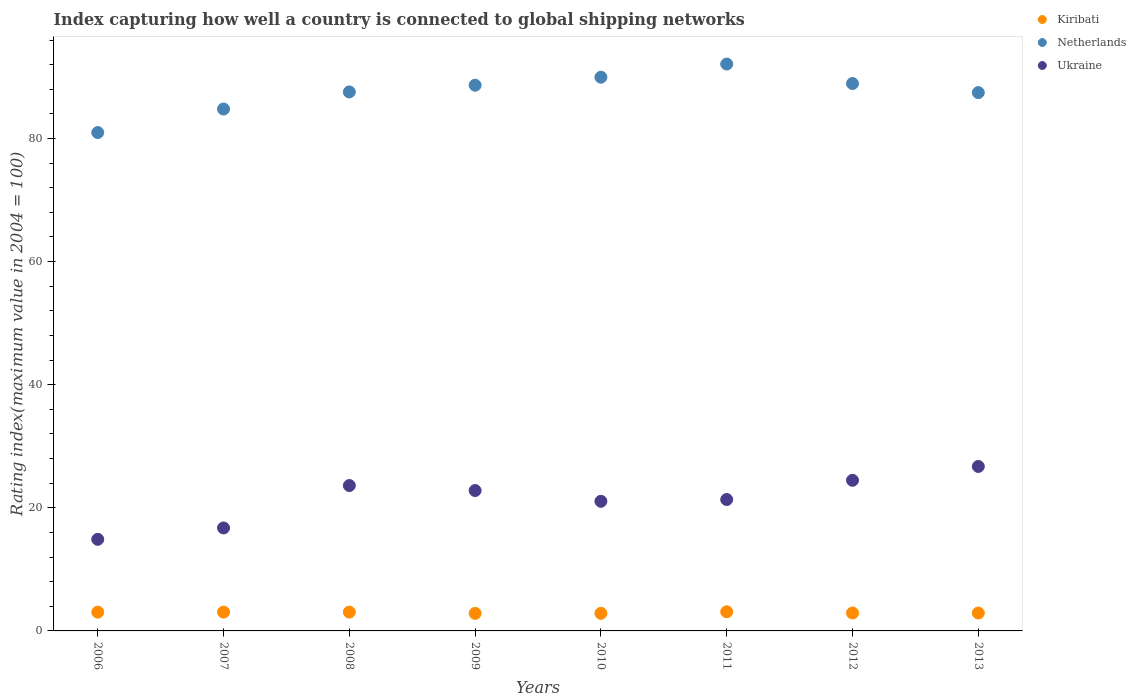Is the number of dotlines equal to the number of legend labels?
Make the answer very short. Yes. What is the rating index in Netherlands in 2009?
Keep it short and to the point. 88.66. Across all years, what is the maximum rating index in Kiribati?
Ensure brevity in your answer.  3.11. Across all years, what is the minimum rating index in Netherlands?
Your response must be concise. 80.97. In which year was the rating index in Ukraine maximum?
Make the answer very short. 2013. What is the total rating index in Kiribati in the graph?
Offer a terse response. 23.81. What is the difference between the rating index in Kiribati in 2009 and that in 2011?
Provide a short and direct response. -0.26. What is the difference between the rating index in Netherlands in 2012 and the rating index in Ukraine in 2009?
Keep it short and to the point. 66.12. What is the average rating index in Ukraine per year?
Your answer should be compact. 21.45. In the year 2013, what is the difference between the rating index in Ukraine and rating index in Kiribati?
Your answer should be very brief. 23.81. In how many years, is the rating index in Netherlands greater than 20?
Offer a very short reply. 8. What is the ratio of the rating index in Ukraine in 2009 to that in 2012?
Give a very brief answer. 0.93. What is the difference between the highest and the second highest rating index in Ukraine?
Offer a very short reply. 2.25. What is the difference between the highest and the lowest rating index in Netherlands?
Provide a short and direct response. 11.13. Is it the case that in every year, the sum of the rating index in Netherlands and rating index in Kiribati  is greater than the rating index in Ukraine?
Your response must be concise. Yes. Does the rating index in Ukraine monotonically increase over the years?
Offer a very short reply. No. Is the rating index in Kiribati strictly less than the rating index in Ukraine over the years?
Give a very brief answer. Yes. How many dotlines are there?
Your response must be concise. 3. How many years are there in the graph?
Give a very brief answer. 8. What is the difference between two consecutive major ticks on the Y-axis?
Provide a succinct answer. 20. How many legend labels are there?
Offer a terse response. 3. How are the legend labels stacked?
Keep it short and to the point. Vertical. What is the title of the graph?
Keep it short and to the point. Index capturing how well a country is connected to global shipping networks. What is the label or title of the X-axis?
Your answer should be very brief. Years. What is the label or title of the Y-axis?
Provide a succinct answer. Rating index(maximum value in 2004 = 100). What is the Rating index(maximum value in 2004 = 100) of Kiribati in 2006?
Provide a succinct answer. 3.05. What is the Rating index(maximum value in 2004 = 100) in Netherlands in 2006?
Offer a very short reply. 80.97. What is the Rating index(maximum value in 2004 = 100) of Ukraine in 2006?
Provide a short and direct response. 14.88. What is the Rating index(maximum value in 2004 = 100) in Kiribati in 2007?
Your answer should be very brief. 3.06. What is the Rating index(maximum value in 2004 = 100) in Netherlands in 2007?
Provide a succinct answer. 84.79. What is the Rating index(maximum value in 2004 = 100) in Ukraine in 2007?
Your answer should be very brief. 16.73. What is the Rating index(maximum value in 2004 = 100) of Kiribati in 2008?
Provide a succinct answer. 3.06. What is the Rating index(maximum value in 2004 = 100) of Netherlands in 2008?
Ensure brevity in your answer.  87.57. What is the Rating index(maximum value in 2004 = 100) in Ukraine in 2008?
Offer a very short reply. 23.62. What is the Rating index(maximum value in 2004 = 100) in Kiribati in 2009?
Provide a short and direct response. 2.85. What is the Rating index(maximum value in 2004 = 100) in Netherlands in 2009?
Provide a short and direct response. 88.66. What is the Rating index(maximum value in 2004 = 100) of Ukraine in 2009?
Provide a succinct answer. 22.81. What is the Rating index(maximum value in 2004 = 100) of Kiribati in 2010?
Offer a terse response. 2.86. What is the Rating index(maximum value in 2004 = 100) in Netherlands in 2010?
Your response must be concise. 89.96. What is the Rating index(maximum value in 2004 = 100) in Ukraine in 2010?
Give a very brief answer. 21.06. What is the Rating index(maximum value in 2004 = 100) of Kiribati in 2011?
Offer a very short reply. 3.11. What is the Rating index(maximum value in 2004 = 100) of Netherlands in 2011?
Your answer should be very brief. 92.1. What is the Rating index(maximum value in 2004 = 100) of Ukraine in 2011?
Offer a terse response. 21.35. What is the Rating index(maximum value in 2004 = 100) of Kiribati in 2012?
Your response must be concise. 2.91. What is the Rating index(maximum value in 2004 = 100) in Netherlands in 2012?
Provide a succinct answer. 88.93. What is the Rating index(maximum value in 2004 = 100) of Ukraine in 2012?
Provide a short and direct response. 24.47. What is the Rating index(maximum value in 2004 = 100) of Kiribati in 2013?
Your answer should be very brief. 2.91. What is the Rating index(maximum value in 2004 = 100) of Netherlands in 2013?
Offer a very short reply. 87.46. What is the Rating index(maximum value in 2004 = 100) in Ukraine in 2013?
Make the answer very short. 26.72. Across all years, what is the maximum Rating index(maximum value in 2004 = 100) of Kiribati?
Make the answer very short. 3.11. Across all years, what is the maximum Rating index(maximum value in 2004 = 100) in Netherlands?
Provide a succinct answer. 92.1. Across all years, what is the maximum Rating index(maximum value in 2004 = 100) in Ukraine?
Provide a short and direct response. 26.72. Across all years, what is the minimum Rating index(maximum value in 2004 = 100) of Kiribati?
Ensure brevity in your answer.  2.85. Across all years, what is the minimum Rating index(maximum value in 2004 = 100) of Netherlands?
Offer a terse response. 80.97. Across all years, what is the minimum Rating index(maximum value in 2004 = 100) of Ukraine?
Your answer should be compact. 14.88. What is the total Rating index(maximum value in 2004 = 100) in Kiribati in the graph?
Provide a short and direct response. 23.81. What is the total Rating index(maximum value in 2004 = 100) in Netherlands in the graph?
Offer a terse response. 700.44. What is the total Rating index(maximum value in 2004 = 100) in Ukraine in the graph?
Your answer should be compact. 171.64. What is the difference between the Rating index(maximum value in 2004 = 100) in Kiribati in 2006 and that in 2007?
Give a very brief answer. -0.01. What is the difference between the Rating index(maximum value in 2004 = 100) of Netherlands in 2006 and that in 2007?
Offer a terse response. -3.82. What is the difference between the Rating index(maximum value in 2004 = 100) of Ukraine in 2006 and that in 2007?
Offer a very short reply. -1.85. What is the difference between the Rating index(maximum value in 2004 = 100) of Kiribati in 2006 and that in 2008?
Offer a very short reply. -0.01. What is the difference between the Rating index(maximum value in 2004 = 100) in Netherlands in 2006 and that in 2008?
Your answer should be compact. -6.6. What is the difference between the Rating index(maximum value in 2004 = 100) in Ukraine in 2006 and that in 2008?
Your response must be concise. -8.74. What is the difference between the Rating index(maximum value in 2004 = 100) of Netherlands in 2006 and that in 2009?
Give a very brief answer. -7.69. What is the difference between the Rating index(maximum value in 2004 = 100) in Ukraine in 2006 and that in 2009?
Your response must be concise. -7.93. What is the difference between the Rating index(maximum value in 2004 = 100) of Kiribati in 2006 and that in 2010?
Provide a succinct answer. 0.19. What is the difference between the Rating index(maximum value in 2004 = 100) of Netherlands in 2006 and that in 2010?
Offer a terse response. -8.99. What is the difference between the Rating index(maximum value in 2004 = 100) of Ukraine in 2006 and that in 2010?
Your answer should be very brief. -6.18. What is the difference between the Rating index(maximum value in 2004 = 100) of Kiribati in 2006 and that in 2011?
Your answer should be compact. -0.06. What is the difference between the Rating index(maximum value in 2004 = 100) of Netherlands in 2006 and that in 2011?
Ensure brevity in your answer.  -11.13. What is the difference between the Rating index(maximum value in 2004 = 100) of Ukraine in 2006 and that in 2011?
Offer a terse response. -6.47. What is the difference between the Rating index(maximum value in 2004 = 100) of Kiribati in 2006 and that in 2012?
Provide a short and direct response. 0.14. What is the difference between the Rating index(maximum value in 2004 = 100) of Netherlands in 2006 and that in 2012?
Your answer should be very brief. -7.96. What is the difference between the Rating index(maximum value in 2004 = 100) of Ukraine in 2006 and that in 2012?
Make the answer very short. -9.59. What is the difference between the Rating index(maximum value in 2004 = 100) in Kiribati in 2006 and that in 2013?
Keep it short and to the point. 0.14. What is the difference between the Rating index(maximum value in 2004 = 100) in Netherlands in 2006 and that in 2013?
Offer a very short reply. -6.49. What is the difference between the Rating index(maximum value in 2004 = 100) in Ukraine in 2006 and that in 2013?
Offer a very short reply. -11.84. What is the difference between the Rating index(maximum value in 2004 = 100) of Netherlands in 2007 and that in 2008?
Provide a succinct answer. -2.78. What is the difference between the Rating index(maximum value in 2004 = 100) in Ukraine in 2007 and that in 2008?
Ensure brevity in your answer.  -6.89. What is the difference between the Rating index(maximum value in 2004 = 100) in Kiribati in 2007 and that in 2009?
Your response must be concise. 0.21. What is the difference between the Rating index(maximum value in 2004 = 100) in Netherlands in 2007 and that in 2009?
Keep it short and to the point. -3.87. What is the difference between the Rating index(maximum value in 2004 = 100) in Ukraine in 2007 and that in 2009?
Offer a terse response. -6.08. What is the difference between the Rating index(maximum value in 2004 = 100) of Kiribati in 2007 and that in 2010?
Provide a short and direct response. 0.2. What is the difference between the Rating index(maximum value in 2004 = 100) in Netherlands in 2007 and that in 2010?
Your response must be concise. -5.17. What is the difference between the Rating index(maximum value in 2004 = 100) of Ukraine in 2007 and that in 2010?
Your answer should be compact. -4.33. What is the difference between the Rating index(maximum value in 2004 = 100) of Kiribati in 2007 and that in 2011?
Your answer should be compact. -0.05. What is the difference between the Rating index(maximum value in 2004 = 100) in Netherlands in 2007 and that in 2011?
Your answer should be compact. -7.31. What is the difference between the Rating index(maximum value in 2004 = 100) of Ukraine in 2007 and that in 2011?
Your response must be concise. -4.62. What is the difference between the Rating index(maximum value in 2004 = 100) of Netherlands in 2007 and that in 2012?
Offer a very short reply. -4.14. What is the difference between the Rating index(maximum value in 2004 = 100) of Ukraine in 2007 and that in 2012?
Offer a very short reply. -7.74. What is the difference between the Rating index(maximum value in 2004 = 100) of Kiribati in 2007 and that in 2013?
Your response must be concise. 0.15. What is the difference between the Rating index(maximum value in 2004 = 100) of Netherlands in 2007 and that in 2013?
Provide a short and direct response. -2.67. What is the difference between the Rating index(maximum value in 2004 = 100) in Ukraine in 2007 and that in 2013?
Provide a short and direct response. -9.99. What is the difference between the Rating index(maximum value in 2004 = 100) in Kiribati in 2008 and that in 2009?
Keep it short and to the point. 0.21. What is the difference between the Rating index(maximum value in 2004 = 100) of Netherlands in 2008 and that in 2009?
Your answer should be compact. -1.09. What is the difference between the Rating index(maximum value in 2004 = 100) of Ukraine in 2008 and that in 2009?
Your response must be concise. 0.81. What is the difference between the Rating index(maximum value in 2004 = 100) in Kiribati in 2008 and that in 2010?
Your answer should be very brief. 0.2. What is the difference between the Rating index(maximum value in 2004 = 100) of Netherlands in 2008 and that in 2010?
Provide a short and direct response. -2.39. What is the difference between the Rating index(maximum value in 2004 = 100) in Ukraine in 2008 and that in 2010?
Keep it short and to the point. 2.56. What is the difference between the Rating index(maximum value in 2004 = 100) of Kiribati in 2008 and that in 2011?
Provide a short and direct response. -0.05. What is the difference between the Rating index(maximum value in 2004 = 100) of Netherlands in 2008 and that in 2011?
Make the answer very short. -4.53. What is the difference between the Rating index(maximum value in 2004 = 100) of Ukraine in 2008 and that in 2011?
Your answer should be compact. 2.27. What is the difference between the Rating index(maximum value in 2004 = 100) of Kiribati in 2008 and that in 2012?
Keep it short and to the point. 0.15. What is the difference between the Rating index(maximum value in 2004 = 100) in Netherlands in 2008 and that in 2012?
Make the answer very short. -1.36. What is the difference between the Rating index(maximum value in 2004 = 100) in Ukraine in 2008 and that in 2012?
Provide a short and direct response. -0.85. What is the difference between the Rating index(maximum value in 2004 = 100) in Netherlands in 2008 and that in 2013?
Your answer should be very brief. 0.11. What is the difference between the Rating index(maximum value in 2004 = 100) in Kiribati in 2009 and that in 2010?
Offer a very short reply. -0.01. What is the difference between the Rating index(maximum value in 2004 = 100) in Ukraine in 2009 and that in 2010?
Keep it short and to the point. 1.75. What is the difference between the Rating index(maximum value in 2004 = 100) of Kiribati in 2009 and that in 2011?
Your answer should be very brief. -0.26. What is the difference between the Rating index(maximum value in 2004 = 100) of Netherlands in 2009 and that in 2011?
Provide a short and direct response. -3.44. What is the difference between the Rating index(maximum value in 2004 = 100) in Ukraine in 2009 and that in 2011?
Your answer should be compact. 1.46. What is the difference between the Rating index(maximum value in 2004 = 100) in Kiribati in 2009 and that in 2012?
Offer a terse response. -0.06. What is the difference between the Rating index(maximum value in 2004 = 100) of Netherlands in 2009 and that in 2012?
Your answer should be compact. -0.27. What is the difference between the Rating index(maximum value in 2004 = 100) in Ukraine in 2009 and that in 2012?
Your response must be concise. -1.66. What is the difference between the Rating index(maximum value in 2004 = 100) of Kiribati in 2009 and that in 2013?
Offer a very short reply. -0.06. What is the difference between the Rating index(maximum value in 2004 = 100) in Ukraine in 2009 and that in 2013?
Provide a short and direct response. -3.91. What is the difference between the Rating index(maximum value in 2004 = 100) of Kiribati in 2010 and that in 2011?
Keep it short and to the point. -0.25. What is the difference between the Rating index(maximum value in 2004 = 100) of Netherlands in 2010 and that in 2011?
Your answer should be very brief. -2.14. What is the difference between the Rating index(maximum value in 2004 = 100) in Ukraine in 2010 and that in 2011?
Give a very brief answer. -0.29. What is the difference between the Rating index(maximum value in 2004 = 100) in Kiribati in 2010 and that in 2012?
Your answer should be compact. -0.05. What is the difference between the Rating index(maximum value in 2004 = 100) in Netherlands in 2010 and that in 2012?
Offer a very short reply. 1.03. What is the difference between the Rating index(maximum value in 2004 = 100) of Ukraine in 2010 and that in 2012?
Ensure brevity in your answer.  -3.41. What is the difference between the Rating index(maximum value in 2004 = 100) in Kiribati in 2010 and that in 2013?
Give a very brief answer. -0.05. What is the difference between the Rating index(maximum value in 2004 = 100) of Ukraine in 2010 and that in 2013?
Ensure brevity in your answer.  -5.66. What is the difference between the Rating index(maximum value in 2004 = 100) in Kiribati in 2011 and that in 2012?
Give a very brief answer. 0.2. What is the difference between the Rating index(maximum value in 2004 = 100) in Netherlands in 2011 and that in 2012?
Provide a succinct answer. 3.17. What is the difference between the Rating index(maximum value in 2004 = 100) in Ukraine in 2011 and that in 2012?
Make the answer very short. -3.12. What is the difference between the Rating index(maximum value in 2004 = 100) in Kiribati in 2011 and that in 2013?
Give a very brief answer. 0.2. What is the difference between the Rating index(maximum value in 2004 = 100) of Netherlands in 2011 and that in 2013?
Offer a very short reply. 4.64. What is the difference between the Rating index(maximum value in 2004 = 100) in Ukraine in 2011 and that in 2013?
Make the answer very short. -5.37. What is the difference between the Rating index(maximum value in 2004 = 100) in Kiribati in 2012 and that in 2013?
Provide a succinct answer. 0. What is the difference between the Rating index(maximum value in 2004 = 100) in Netherlands in 2012 and that in 2013?
Keep it short and to the point. 1.47. What is the difference between the Rating index(maximum value in 2004 = 100) in Ukraine in 2012 and that in 2013?
Provide a short and direct response. -2.25. What is the difference between the Rating index(maximum value in 2004 = 100) in Kiribati in 2006 and the Rating index(maximum value in 2004 = 100) in Netherlands in 2007?
Provide a succinct answer. -81.74. What is the difference between the Rating index(maximum value in 2004 = 100) of Kiribati in 2006 and the Rating index(maximum value in 2004 = 100) of Ukraine in 2007?
Your response must be concise. -13.68. What is the difference between the Rating index(maximum value in 2004 = 100) of Netherlands in 2006 and the Rating index(maximum value in 2004 = 100) of Ukraine in 2007?
Your answer should be very brief. 64.24. What is the difference between the Rating index(maximum value in 2004 = 100) in Kiribati in 2006 and the Rating index(maximum value in 2004 = 100) in Netherlands in 2008?
Make the answer very short. -84.52. What is the difference between the Rating index(maximum value in 2004 = 100) of Kiribati in 2006 and the Rating index(maximum value in 2004 = 100) of Ukraine in 2008?
Offer a terse response. -20.57. What is the difference between the Rating index(maximum value in 2004 = 100) in Netherlands in 2006 and the Rating index(maximum value in 2004 = 100) in Ukraine in 2008?
Provide a short and direct response. 57.35. What is the difference between the Rating index(maximum value in 2004 = 100) in Kiribati in 2006 and the Rating index(maximum value in 2004 = 100) in Netherlands in 2009?
Provide a short and direct response. -85.61. What is the difference between the Rating index(maximum value in 2004 = 100) in Kiribati in 2006 and the Rating index(maximum value in 2004 = 100) in Ukraine in 2009?
Ensure brevity in your answer.  -19.76. What is the difference between the Rating index(maximum value in 2004 = 100) of Netherlands in 2006 and the Rating index(maximum value in 2004 = 100) of Ukraine in 2009?
Offer a very short reply. 58.16. What is the difference between the Rating index(maximum value in 2004 = 100) in Kiribati in 2006 and the Rating index(maximum value in 2004 = 100) in Netherlands in 2010?
Ensure brevity in your answer.  -86.91. What is the difference between the Rating index(maximum value in 2004 = 100) in Kiribati in 2006 and the Rating index(maximum value in 2004 = 100) in Ukraine in 2010?
Provide a short and direct response. -18.01. What is the difference between the Rating index(maximum value in 2004 = 100) of Netherlands in 2006 and the Rating index(maximum value in 2004 = 100) of Ukraine in 2010?
Provide a short and direct response. 59.91. What is the difference between the Rating index(maximum value in 2004 = 100) in Kiribati in 2006 and the Rating index(maximum value in 2004 = 100) in Netherlands in 2011?
Keep it short and to the point. -89.05. What is the difference between the Rating index(maximum value in 2004 = 100) of Kiribati in 2006 and the Rating index(maximum value in 2004 = 100) of Ukraine in 2011?
Ensure brevity in your answer.  -18.3. What is the difference between the Rating index(maximum value in 2004 = 100) in Netherlands in 2006 and the Rating index(maximum value in 2004 = 100) in Ukraine in 2011?
Give a very brief answer. 59.62. What is the difference between the Rating index(maximum value in 2004 = 100) in Kiribati in 2006 and the Rating index(maximum value in 2004 = 100) in Netherlands in 2012?
Make the answer very short. -85.88. What is the difference between the Rating index(maximum value in 2004 = 100) of Kiribati in 2006 and the Rating index(maximum value in 2004 = 100) of Ukraine in 2012?
Provide a short and direct response. -21.42. What is the difference between the Rating index(maximum value in 2004 = 100) of Netherlands in 2006 and the Rating index(maximum value in 2004 = 100) of Ukraine in 2012?
Make the answer very short. 56.5. What is the difference between the Rating index(maximum value in 2004 = 100) in Kiribati in 2006 and the Rating index(maximum value in 2004 = 100) in Netherlands in 2013?
Give a very brief answer. -84.41. What is the difference between the Rating index(maximum value in 2004 = 100) in Kiribati in 2006 and the Rating index(maximum value in 2004 = 100) in Ukraine in 2013?
Offer a very short reply. -23.67. What is the difference between the Rating index(maximum value in 2004 = 100) in Netherlands in 2006 and the Rating index(maximum value in 2004 = 100) in Ukraine in 2013?
Provide a short and direct response. 54.25. What is the difference between the Rating index(maximum value in 2004 = 100) of Kiribati in 2007 and the Rating index(maximum value in 2004 = 100) of Netherlands in 2008?
Make the answer very short. -84.51. What is the difference between the Rating index(maximum value in 2004 = 100) of Kiribati in 2007 and the Rating index(maximum value in 2004 = 100) of Ukraine in 2008?
Give a very brief answer. -20.56. What is the difference between the Rating index(maximum value in 2004 = 100) of Netherlands in 2007 and the Rating index(maximum value in 2004 = 100) of Ukraine in 2008?
Your response must be concise. 61.17. What is the difference between the Rating index(maximum value in 2004 = 100) of Kiribati in 2007 and the Rating index(maximum value in 2004 = 100) of Netherlands in 2009?
Make the answer very short. -85.6. What is the difference between the Rating index(maximum value in 2004 = 100) of Kiribati in 2007 and the Rating index(maximum value in 2004 = 100) of Ukraine in 2009?
Provide a succinct answer. -19.75. What is the difference between the Rating index(maximum value in 2004 = 100) in Netherlands in 2007 and the Rating index(maximum value in 2004 = 100) in Ukraine in 2009?
Offer a very short reply. 61.98. What is the difference between the Rating index(maximum value in 2004 = 100) in Kiribati in 2007 and the Rating index(maximum value in 2004 = 100) in Netherlands in 2010?
Your answer should be compact. -86.9. What is the difference between the Rating index(maximum value in 2004 = 100) in Kiribati in 2007 and the Rating index(maximum value in 2004 = 100) in Ukraine in 2010?
Offer a terse response. -18. What is the difference between the Rating index(maximum value in 2004 = 100) in Netherlands in 2007 and the Rating index(maximum value in 2004 = 100) in Ukraine in 2010?
Your answer should be compact. 63.73. What is the difference between the Rating index(maximum value in 2004 = 100) of Kiribati in 2007 and the Rating index(maximum value in 2004 = 100) of Netherlands in 2011?
Offer a terse response. -89.04. What is the difference between the Rating index(maximum value in 2004 = 100) of Kiribati in 2007 and the Rating index(maximum value in 2004 = 100) of Ukraine in 2011?
Your answer should be very brief. -18.29. What is the difference between the Rating index(maximum value in 2004 = 100) in Netherlands in 2007 and the Rating index(maximum value in 2004 = 100) in Ukraine in 2011?
Keep it short and to the point. 63.44. What is the difference between the Rating index(maximum value in 2004 = 100) of Kiribati in 2007 and the Rating index(maximum value in 2004 = 100) of Netherlands in 2012?
Offer a very short reply. -85.87. What is the difference between the Rating index(maximum value in 2004 = 100) in Kiribati in 2007 and the Rating index(maximum value in 2004 = 100) in Ukraine in 2012?
Ensure brevity in your answer.  -21.41. What is the difference between the Rating index(maximum value in 2004 = 100) of Netherlands in 2007 and the Rating index(maximum value in 2004 = 100) of Ukraine in 2012?
Your answer should be very brief. 60.32. What is the difference between the Rating index(maximum value in 2004 = 100) in Kiribati in 2007 and the Rating index(maximum value in 2004 = 100) in Netherlands in 2013?
Offer a very short reply. -84.4. What is the difference between the Rating index(maximum value in 2004 = 100) in Kiribati in 2007 and the Rating index(maximum value in 2004 = 100) in Ukraine in 2013?
Ensure brevity in your answer.  -23.66. What is the difference between the Rating index(maximum value in 2004 = 100) in Netherlands in 2007 and the Rating index(maximum value in 2004 = 100) in Ukraine in 2013?
Offer a terse response. 58.07. What is the difference between the Rating index(maximum value in 2004 = 100) of Kiribati in 2008 and the Rating index(maximum value in 2004 = 100) of Netherlands in 2009?
Give a very brief answer. -85.6. What is the difference between the Rating index(maximum value in 2004 = 100) in Kiribati in 2008 and the Rating index(maximum value in 2004 = 100) in Ukraine in 2009?
Provide a succinct answer. -19.75. What is the difference between the Rating index(maximum value in 2004 = 100) in Netherlands in 2008 and the Rating index(maximum value in 2004 = 100) in Ukraine in 2009?
Your answer should be very brief. 64.76. What is the difference between the Rating index(maximum value in 2004 = 100) in Kiribati in 2008 and the Rating index(maximum value in 2004 = 100) in Netherlands in 2010?
Provide a short and direct response. -86.9. What is the difference between the Rating index(maximum value in 2004 = 100) of Netherlands in 2008 and the Rating index(maximum value in 2004 = 100) of Ukraine in 2010?
Keep it short and to the point. 66.51. What is the difference between the Rating index(maximum value in 2004 = 100) of Kiribati in 2008 and the Rating index(maximum value in 2004 = 100) of Netherlands in 2011?
Make the answer very short. -89.04. What is the difference between the Rating index(maximum value in 2004 = 100) of Kiribati in 2008 and the Rating index(maximum value in 2004 = 100) of Ukraine in 2011?
Offer a terse response. -18.29. What is the difference between the Rating index(maximum value in 2004 = 100) of Netherlands in 2008 and the Rating index(maximum value in 2004 = 100) of Ukraine in 2011?
Offer a very short reply. 66.22. What is the difference between the Rating index(maximum value in 2004 = 100) of Kiribati in 2008 and the Rating index(maximum value in 2004 = 100) of Netherlands in 2012?
Give a very brief answer. -85.87. What is the difference between the Rating index(maximum value in 2004 = 100) of Kiribati in 2008 and the Rating index(maximum value in 2004 = 100) of Ukraine in 2012?
Offer a terse response. -21.41. What is the difference between the Rating index(maximum value in 2004 = 100) of Netherlands in 2008 and the Rating index(maximum value in 2004 = 100) of Ukraine in 2012?
Ensure brevity in your answer.  63.1. What is the difference between the Rating index(maximum value in 2004 = 100) of Kiribati in 2008 and the Rating index(maximum value in 2004 = 100) of Netherlands in 2013?
Ensure brevity in your answer.  -84.4. What is the difference between the Rating index(maximum value in 2004 = 100) in Kiribati in 2008 and the Rating index(maximum value in 2004 = 100) in Ukraine in 2013?
Your answer should be compact. -23.66. What is the difference between the Rating index(maximum value in 2004 = 100) in Netherlands in 2008 and the Rating index(maximum value in 2004 = 100) in Ukraine in 2013?
Your answer should be compact. 60.85. What is the difference between the Rating index(maximum value in 2004 = 100) of Kiribati in 2009 and the Rating index(maximum value in 2004 = 100) of Netherlands in 2010?
Make the answer very short. -87.11. What is the difference between the Rating index(maximum value in 2004 = 100) in Kiribati in 2009 and the Rating index(maximum value in 2004 = 100) in Ukraine in 2010?
Make the answer very short. -18.21. What is the difference between the Rating index(maximum value in 2004 = 100) in Netherlands in 2009 and the Rating index(maximum value in 2004 = 100) in Ukraine in 2010?
Provide a succinct answer. 67.6. What is the difference between the Rating index(maximum value in 2004 = 100) of Kiribati in 2009 and the Rating index(maximum value in 2004 = 100) of Netherlands in 2011?
Offer a very short reply. -89.25. What is the difference between the Rating index(maximum value in 2004 = 100) of Kiribati in 2009 and the Rating index(maximum value in 2004 = 100) of Ukraine in 2011?
Keep it short and to the point. -18.5. What is the difference between the Rating index(maximum value in 2004 = 100) of Netherlands in 2009 and the Rating index(maximum value in 2004 = 100) of Ukraine in 2011?
Offer a very short reply. 67.31. What is the difference between the Rating index(maximum value in 2004 = 100) in Kiribati in 2009 and the Rating index(maximum value in 2004 = 100) in Netherlands in 2012?
Make the answer very short. -86.08. What is the difference between the Rating index(maximum value in 2004 = 100) in Kiribati in 2009 and the Rating index(maximum value in 2004 = 100) in Ukraine in 2012?
Your response must be concise. -21.62. What is the difference between the Rating index(maximum value in 2004 = 100) in Netherlands in 2009 and the Rating index(maximum value in 2004 = 100) in Ukraine in 2012?
Provide a short and direct response. 64.19. What is the difference between the Rating index(maximum value in 2004 = 100) in Kiribati in 2009 and the Rating index(maximum value in 2004 = 100) in Netherlands in 2013?
Offer a terse response. -84.61. What is the difference between the Rating index(maximum value in 2004 = 100) of Kiribati in 2009 and the Rating index(maximum value in 2004 = 100) of Ukraine in 2013?
Ensure brevity in your answer.  -23.87. What is the difference between the Rating index(maximum value in 2004 = 100) in Netherlands in 2009 and the Rating index(maximum value in 2004 = 100) in Ukraine in 2013?
Make the answer very short. 61.94. What is the difference between the Rating index(maximum value in 2004 = 100) of Kiribati in 2010 and the Rating index(maximum value in 2004 = 100) of Netherlands in 2011?
Provide a short and direct response. -89.24. What is the difference between the Rating index(maximum value in 2004 = 100) in Kiribati in 2010 and the Rating index(maximum value in 2004 = 100) in Ukraine in 2011?
Offer a very short reply. -18.49. What is the difference between the Rating index(maximum value in 2004 = 100) of Netherlands in 2010 and the Rating index(maximum value in 2004 = 100) of Ukraine in 2011?
Ensure brevity in your answer.  68.61. What is the difference between the Rating index(maximum value in 2004 = 100) in Kiribati in 2010 and the Rating index(maximum value in 2004 = 100) in Netherlands in 2012?
Your answer should be compact. -86.07. What is the difference between the Rating index(maximum value in 2004 = 100) in Kiribati in 2010 and the Rating index(maximum value in 2004 = 100) in Ukraine in 2012?
Provide a succinct answer. -21.61. What is the difference between the Rating index(maximum value in 2004 = 100) of Netherlands in 2010 and the Rating index(maximum value in 2004 = 100) of Ukraine in 2012?
Make the answer very short. 65.49. What is the difference between the Rating index(maximum value in 2004 = 100) of Kiribati in 2010 and the Rating index(maximum value in 2004 = 100) of Netherlands in 2013?
Your response must be concise. -84.6. What is the difference between the Rating index(maximum value in 2004 = 100) in Kiribati in 2010 and the Rating index(maximum value in 2004 = 100) in Ukraine in 2013?
Provide a succinct answer. -23.86. What is the difference between the Rating index(maximum value in 2004 = 100) in Netherlands in 2010 and the Rating index(maximum value in 2004 = 100) in Ukraine in 2013?
Offer a terse response. 63.24. What is the difference between the Rating index(maximum value in 2004 = 100) of Kiribati in 2011 and the Rating index(maximum value in 2004 = 100) of Netherlands in 2012?
Give a very brief answer. -85.82. What is the difference between the Rating index(maximum value in 2004 = 100) in Kiribati in 2011 and the Rating index(maximum value in 2004 = 100) in Ukraine in 2012?
Your answer should be very brief. -21.36. What is the difference between the Rating index(maximum value in 2004 = 100) of Netherlands in 2011 and the Rating index(maximum value in 2004 = 100) of Ukraine in 2012?
Ensure brevity in your answer.  67.63. What is the difference between the Rating index(maximum value in 2004 = 100) of Kiribati in 2011 and the Rating index(maximum value in 2004 = 100) of Netherlands in 2013?
Keep it short and to the point. -84.35. What is the difference between the Rating index(maximum value in 2004 = 100) in Kiribati in 2011 and the Rating index(maximum value in 2004 = 100) in Ukraine in 2013?
Give a very brief answer. -23.61. What is the difference between the Rating index(maximum value in 2004 = 100) in Netherlands in 2011 and the Rating index(maximum value in 2004 = 100) in Ukraine in 2013?
Offer a very short reply. 65.38. What is the difference between the Rating index(maximum value in 2004 = 100) of Kiribati in 2012 and the Rating index(maximum value in 2004 = 100) of Netherlands in 2013?
Your response must be concise. -84.55. What is the difference between the Rating index(maximum value in 2004 = 100) in Kiribati in 2012 and the Rating index(maximum value in 2004 = 100) in Ukraine in 2013?
Your response must be concise. -23.81. What is the difference between the Rating index(maximum value in 2004 = 100) in Netherlands in 2012 and the Rating index(maximum value in 2004 = 100) in Ukraine in 2013?
Make the answer very short. 62.21. What is the average Rating index(maximum value in 2004 = 100) in Kiribati per year?
Give a very brief answer. 2.98. What is the average Rating index(maximum value in 2004 = 100) in Netherlands per year?
Provide a succinct answer. 87.56. What is the average Rating index(maximum value in 2004 = 100) in Ukraine per year?
Ensure brevity in your answer.  21.45. In the year 2006, what is the difference between the Rating index(maximum value in 2004 = 100) of Kiribati and Rating index(maximum value in 2004 = 100) of Netherlands?
Provide a short and direct response. -77.92. In the year 2006, what is the difference between the Rating index(maximum value in 2004 = 100) of Kiribati and Rating index(maximum value in 2004 = 100) of Ukraine?
Give a very brief answer. -11.83. In the year 2006, what is the difference between the Rating index(maximum value in 2004 = 100) of Netherlands and Rating index(maximum value in 2004 = 100) of Ukraine?
Ensure brevity in your answer.  66.09. In the year 2007, what is the difference between the Rating index(maximum value in 2004 = 100) of Kiribati and Rating index(maximum value in 2004 = 100) of Netherlands?
Your response must be concise. -81.73. In the year 2007, what is the difference between the Rating index(maximum value in 2004 = 100) in Kiribati and Rating index(maximum value in 2004 = 100) in Ukraine?
Offer a terse response. -13.67. In the year 2007, what is the difference between the Rating index(maximum value in 2004 = 100) in Netherlands and Rating index(maximum value in 2004 = 100) in Ukraine?
Give a very brief answer. 68.06. In the year 2008, what is the difference between the Rating index(maximum value in 2004 = 100) in Kiribati and Rating index(maximum value in 2004 = 100) in Netherlands?
Provide a succinct answer. -84.51. In the year 2008, what is the difference between the Rating index(maximum value in 2004 = 100) of Kiribati and Rating index(maximum value in 2004 = 100) of Ukraine?
Offer a terse response. -20.56. In the year 2008, what is the difference between the Rating index(maximum value in 2004 = 100) in Netherlands and Rating index(maximum value in 2004 = 100) in Ukraine?
Ensure brevity in your answer.  63.95. In the year 2009, what is the difference between the Rating index(maximum value in 2004 = 100) in Kiribati and Rating index(maximum value in 2004 = 100) in Netherlands?
Your answer should be compact. -85.81. In the year 2009, what is the difference between the Rating index(maximum value in 2004 = 100) in Kiribati and Rating index(maximum value in 2004 = 100) in Ukraine?
Provide a succinct answer. -19.96. In the year 2009, what is the difference between the Rating index(maximum value in 2004 = 100) of Netherlands and Rating index(maximum value in 2004 = 100) of Ukraine?
Offer a terse response. 65.85. In the year 2010, what is the difference between the Rating index(maximum value in 2004 = 100) in Kiribati and Rating index(maximum value in 2004 = 100) in Netherlands?
Provide a succinct answer. -87.1. In the year 2010, what is the difference between the Rating index(maximum value in 2004 = 100) in Kiribati and Rating index(maximum value in 2004 = 100) in Ukraine?
Offer a terse response. -18.2. In the year 2010, what is the difference between the Rating index(maximum value in 2004 = 100) of Netherlands and Rating index(maximum value in 2004 = 100) of Ukraine?
Provide a short and direct response. 68.9. In the year 2011, what is the difference between the Rating index(maximum value in 2004 = 100) in Kiribati and Rating index(maximum value in 2004 = 100) in Netherlands?
Keep it short and to the point. -88.99. In the year 2011, what is the difference between the Rating index(maximum value in 2004 = 100) of Kiribati and Rating index(maximum value in 2004 = 100) of Ukraine?
Give a very brief answer. -18.24. In the year 2011, what is the difference between the Rating index(maximum value in 2004 = 100) of Netherlands and Rating index(maximum value in 2004 = 100) of Ukraine?
Provide a succinct answer. 70.75. In the year 2012, what is the difference between the Rating index(maximum value in 2004 = 100) of Kiribati and Rating index(maximum value in 2004 = 100) of Netherlands?
Your answer should be compact. -86.02. In the year 2012, what is the difference between the Rating index(maximum value in 2004 = 100) of Kiribati and Rating index(maximum value in 2004 = 100) of Ukraine?
Keep it short and to the point. -21.56. In the year 2012, what is the difference between the Rating index(maximum value in 2004 = 100) of Netherlands and Rating index(maximum value in 2004 = 100) of Ukraine?
Offer a terse response. 64.46. In the year 2013, what is the difference between the Rating index(maximum value in 2004 = 100) in Kiribati and Rating index(maximum value in 2004 = 100) in Netherlands?
Offer a terse response. -84.55. In the year 2013, what is the difference between the Rating index(maximum value in 2004 = 100) in Kiribati and Rating index(maximum value in 2004 = 100) in Ukraine?
Ensure brevity in your answer.  -23.81. In the year 2013, what is the difference between the Rating index(maximum value in 2004 = 100) of Netherlands and Rating index(maximum value in 2004 = 100) of Ukraine?
Your answer should be compact. 60.74. What is the ratio of the Rating index(maximum value in 2004 = 100) in Kiribati in 2006 to that in 2007?
Offer a terse response. 1. What is the ratio of the Rating index(maximum value in 2004 = 100) of Netherlands in 2006 to that in 2007?
Your answer should be very brief. 0.95. What is the ratio of the Rating index(maximum value in 2004 = 100) of Ukraine in 2006 to that in 2007?
Keep it short and to the point. 0.89. What is the ratio of the Rating index(maximum value in 2004 = 100) in Netherlands in 2006 to that in 2008?
Ensure brevity in your answer.  0.92. What is the ratio of the Rating index(maximum value in 2004 = 100) of Ukraine in 2006 to that in 2008?
Provide a succinct answer. 0.63. What is the ratio of the Rating index(maximum value in 2004 = 100) of Kiribati in 2006 to that in 2009?
Provide a succinct answer. 1.07. What is the ratio of the Rating index(maximum value in 2004 = 100) in Netherlands in 2006 to that in 2009?
Keep it short and to the point. 0.91. What is the ratio of the Rating index(maximum value in 2004 = 100) of Ukraine in 2006 to that in 2009?
Make the answer very short. 0.65. What is the ratio of the Rating index(maximum value in 2004 = 100) in Kiribati in 2006 to that in 2010?
Keep it short and to the point. 1.07. What is the ratio of the Rating index(maximum value in 2004 = 100) of Netherlands in 2006 to that in 2010?
Offer a very short reply. 0.9. What is the ratio of the Rating index(maximum value in 2004 = 100) in Ukraine in 2006 to that in 2010?
Your answer should be very brief. 0.71. What is the ratio of the Rating index(maximum value in 2004 = 100) of Kiribati in 2006 to that in 2011?
Keep it short and to the point. 0.98. What is the ratio of the Rating index(maximum value in 2004 = 100) of Netherlands in 2006 to that in 2011?
Your answer should be compact. 0.88. What is the ratio of the Rating index(maximum value in 2004 = 100) in Ukraine in 2006 to that in 2011?
Provide a succinct answer. 0.7. What is the ratio of the Rating index(maximum value in 2004 = 100) in Kiribati in 2006 to that in 2012?
Offer a terse response. 1.05. What is the ratio of the Rating index(maximum value in 2004 = 100) in Netherlands in 2006 to that in 2012?
Your response must be concise. 0.91. What is the ratio of the Rating index(maximum value in 2004 = 100) in Ukraine in 2006 to that in 2012?
Keep it short and to the point. 0.61. What is the ratio of the Rating index(maximum value in 2004 = 100) in Kiribati in 2006 to that in 2013?
Your response must be concise. 1.05. What is the ratio of the Rating index(maximum value in 2004 = 100) in Netherlands in 2006 to that in 2013?
Keep it short and to the point. 0.93. What is the ratio of the Rating index(maximum value in 2004 = 100) in Ukraine in 2006 to that in 2013?
Your response must be concise. 0.56. What is the ratio of the Rating index(maximum value in 2004 = 100) of Netherlands in 2007 to that in 2008?
Provide a succinct answer. 0.97. What is the ratio of the Rating index(maximum value in 2004 = 100) in Ukraine in 2007 to that in 2008?
Make the answer very short. 0.71. What is the ratio of the Rating index(maximum value in 2004 = 100) in Kiribati in 2007 to that in 2009?
Give a very brief answer. 1.07. What is the ratio of the Rating index(maximum value in 2004 = 100) of Netherlands in 2007 to that in 2009?
Ensure brevity in your answer.  0.96. What is the ratio of the Rating index(maximum value in 2004 = 100) in Ukraine in 2007 to that in 2009?
Provide a succinct answer. 0.73. What is the ratio of the Rating index(maximum value in 2004 = 100) of Kiribati in 2007 to that in 2010?
Your response must be concise. 1.07. What is the ratio of the Rating index(maximum value in 2004 = 100) of Netherlands in 2007 to that in 2010?
Your response must be concise. 0.94. What is the ratio of the Rating index(maximum value in 2004 = 100) of Ukraine in 2007 to that in 2010?
Give a very brief answer. 0.79. What is the ratio of the Rating index(maximum value in 2004 = 100) of Kiribati in 2007 to that in 2011?
Make the answer very short. 0.98. What is the ratio of the Rating index(maximum value in 2004 = 100) of Netherlands in 2007 to that in 2011?
Your response must be concise. 0.92. What is the ratio of the Rating index(maximum value in 2004 = 100) in Ukraine in 2007 to that in 2011?
Provide a short and direct response. 0.78. What is the ratio of the Rating index(maximum value in 2004 = 100) of Kiribati in 2007 to that in 2012?
Make the answer very short. 1.05. What is the ratio of the Rating index(maximum value in 2004 = 100) in Netherlands in 2007 to that in 2012?
Provide a short and direct response. 0.95. What is the ratio of the Rating index(maximum value in 2004 = 100) in Ukraine in 2007 to that in 2012?
Your response must be concise. 0.68. What is the ratio of the Rating index(maximum value in 2004 = 100) of Kiribati in 2007 to that in 2013?
Provide a succinct answer. 1.05. What is the ratio of the Rating index(maximum value in 2004 = 100) of Netherlands in 2007 to that in 2013?
Ensure brevity in your answer.  0.97. What is the ratio of the Rating index(maximum value in 2004 = 100) in Ukraine in 2007 to that in 2013?
Provide a short and direct response. 0.63. What is the ratio of the Rating index(maximum value in 2004 = 100) in Kiribati in 2008 to that in 2009?
Your answer should be compact. 1.07. What is the ratio of the Rating index(maximum value in 2004 = 100) of Ukraine in 2008 to that in 2009?
Make the answer very short. 1.04. What is the ratio of the Rating index(maximum value in 2004 = 100) in Kiribati in 2008 to that in 2010?
Make the answer very short. 1.07. What is the ratio of the Rating index(maximum value in 2004 = 100) of Netherlands in 2008 to that in 2010?
Provide a succinct answer. 0.97. What is the ratio of the Rating index(maximum value in 2004 = 100) of Ukraine in 2008 to that in 2010?
Make the answer very short. 1.12. What is the ratio of the Rating index(maximum value in 2004 = 100) of Kiribati in 2008 to that in 2011?
Offer a terse response. 0.98. What is the ratio of the Rating index(maximum value in 2004 = 100) of Netherlands in 2008 to that in 2011?
Your response must be concise. 0.95. What is the ratio of the Rating index(maximum value in 2004 = 100) in Ukraine in 2008 to that in 2011?
Provide a short and direct response. 1.11. What is the ratio of the Rating index(maximum value in 2004 = 100) of Kiribati in 2008 to that in 2012?
Make the answer very short. 1.05. What is the ratio of the Rating index(maximum value in 2004 = 100) in Netherlands in 2008 to that in 2012?
Your answer should be compact. 0.98. What is the ratio of the Rating index(maximum value in 2004 = 100) of Ukraine in 2008 to that in 2012?
Your response must be concise. 0.97. What is the ratio of the Rating index(maximum value in 2004 = 100) of Kiribati in 2008 to that in 2013?
Offer a terse response. 1.05. What is the ratio of the Rating index(maximum value in 2004 = 100) of Ukraine in 2008 to that in 2013?
Your response must be concise. 0.88. What is the ratio of the Rating index(maximum value in 2004 = 100) of Netherlands in 2009 to that in 2010?
Your response must be concise. 0.99. What is the ratio of the Rating index(maximum value in 2004 = 100) of Ukraine in 2009 to that in 2010?
Give a very brief answer. 1.08. What is the ratio of the Rating index(maximum value in 2004 = 100) in Kiribati in 2009 to that in 2011?
Offer a very short reply. 0.92. What is the ratio of the Rating index(maximum value in 2004 = 100) of Netherlands in 2009 to that in 2011?
Give a very brief answer. 0.96. What is the ratio of the Rating index(maximum value in 2004 = 100) in Ukraine in 2009 to that in 2011?
Your answer should be compact. 1.07. What is the ratio of the Rating index(maximum value in 2004 = 100) of Kiribati in 2009 to that in 2012?
Offer a very short reply. 0.98. What is the ratio of the Rating index(maximum value in 2004 = 100) of Ukraine in 2009 to that in 2012?
Your answer should be compact. 0.93. What is the ratio of the Rating index(maximum value in 2004 = 100) in Kiribati in 2009 to that in 2013?
Ensure brevity in your answer.  0.98. What is the ratio of the Rating index(maximum value in 2004 = 100) in Netherlands in 2009 to that in 2013?
Make the answer very short. 1.01. What is the ratio of the Rating index(maximum value in 2004 = 100) of Ukraine in 2009 to that in 2013?
Offer a terse response. 0.85. What is the ratio of the Rating index(maximum value in 2004 = 100) in Kiribati in 2010 to that in 2011?
Provide a short and direct response. 0.92. What is the ratio of the Rating index(maximum value in 2004 = 100) of Netherlands in 2010 to that in 2011?
Offer a terse response. 0.98. What is the ratio of the Rating index(maximum value in 2004 = 100) in Ukraine in 2010 to that in 2011?
Your response must be concise. 0.99. What is the ratio of the Rating index(maximum value in 2004 = 100) of Kiribati in 2010 to that in 2012?
Offer a terse response. 0.98. What is the ratio of the Rating index(maximum value in 2004 = 100) in Netherlands in 2010 to that in 2012?
Provide a short and direct response. 1.01. What is the ratio of the Rating index(maximum value in 2004 = 100) of Ukraine in 2010 to that in 2012?
Offer a terse response. 0.86. What is the ratio of the Rating index(maximum value in 2004 = 100) in Kiribati in 2010 to that in 2013?
Your answer should be compact. 0.98. What is the ratio of the Rating index(maximum value in 2004 = 100) of Netherlands in 2010 to that in 2013?
Your response must be concise. 1.03. What is the ratio of the Rating index(maximum value in 2004 = 100) of Ukraine in 2010 to that in 2013?
Your response must be concise. 0.79. What is the ratio of the Rating index(maximum value in 2004 = 100) of Kiribati in 2011 to that in 2012?
Keep it short and to the point. 1.07. What is the ratio of the Rating index(maximum value in 2004 = 100) of Netherlands in 2011 to that in 2012?
Offer a terse response. 1.04. What is the ratio of the Rating index(maximum value in 2004 = 100) in Ukraine in 2011 to that in 2012?
Ensure brevity in your answer.  0.87. What is the ratio of the Rating index(maximum value in 2004 = 100) in Kiribati in 2011 to that in 2013?
Offer a terse response. 1.07. What is the ratio of the Rating index(maximum value in 2004 = 100) of Netherlands in 2011 to that in 2013?
Ensure brevity in your answer.  1.05. What is the ratio of the Rating index(maximum value in 2004 = 100) of Ukraine in 2011 to that in 2013?
Keep it short and to the point. 0.8. What is the ratio of the Rating index(maximum value in 2004 = 100) of Netherlands in 2012 to that in 2013?
Give a very brief answer. 1.02. What is the ratio of the Rating index(maximum value in 2004 = 100) of Ukraine in 2012 to that in 2013?
Offer a very short reply. 0.92. What is the difference between the highest and the second highest Rating index(maximum value in 2004 = 100) in Kiribati?
Your answer should be very brief. 0.05. What is the difference between the highest and the second highest Rating index(maximum value in 2004 = 100) in Netherlands?
Give a very brief answer. 2.14. What is the difference between the highest and the second highest Rating index(maximum value in 2004 = 100) in Ukraine?
Provide a short and direct response. 2.25. What is the difference between the highest and the lowest Rating index(maximum value in 2004 = 100) in Kiribati?
Your answer should be compact. 0.26. What is the difference between the highest and the lowest Rating index(maximum value in 2004 = 100) of Netherlands?
Your answer should be very brief. 11.13. What is the difference between the highest and the lowest Rating index(maximum value in 2004 = 100) of Ukraine?
Your answer should be compact. 11.84. 